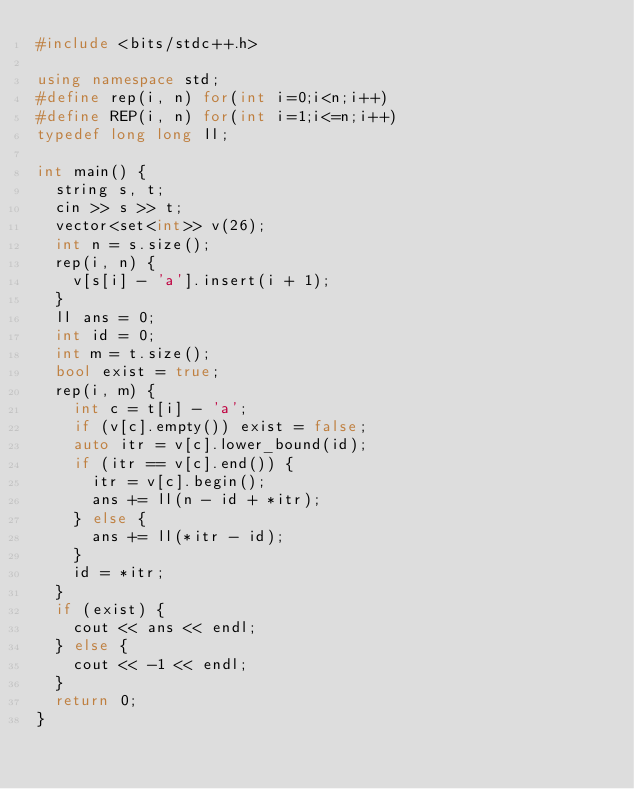Convert code to text. <code><loc_0><loc_0><loc_500><loc_500><_C++_>#include <bits/stdc++.h>

using namespace std;
#define rep(i, n) for(int i=0;i<n;i++)
#define REP(i, n) for(int i=1;i<=n;i++)
typedef long long ll;

int main() {
	string s, t;
	cin >> s >> t;
	vector<set<int>> v(26);
	int n = s.size();
	rep(i, n) {
		v[s[i] - 'a'].insert(i + 1);
	}
	ll ans = 0;
	int id = 0;
	int m = t.size();
	bool exist = true;
	rep(i, m) {
		int c = t[i] - 'a';
		if (v[c].empty()) exist = false;
		auto itr = v[c].lower_bound(id);
		if (itr == v[c].end()) {
			itr = v[c].begin();
			ans += ll(n - id + *itr);
		} else {
			ans += ll(*itr - id);
		}
		id = *itr;
	}
	if (exist) {
		cout << ans << endl;
	} else {
		cout << -1 << endl;
	}
	return 0;
}</code> 